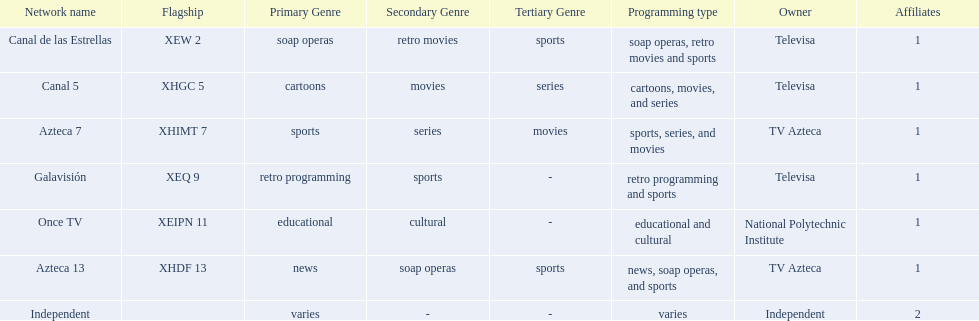Which owner only owns one network? National Polytechnic Institute, Independent. Of those, what is the network name? Once TV, Independent. Of those, which programming type is educational and cultural? Once TV. 